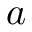<formula> <loc_0><loc_0><loc_500><loc_500>a</formula> 